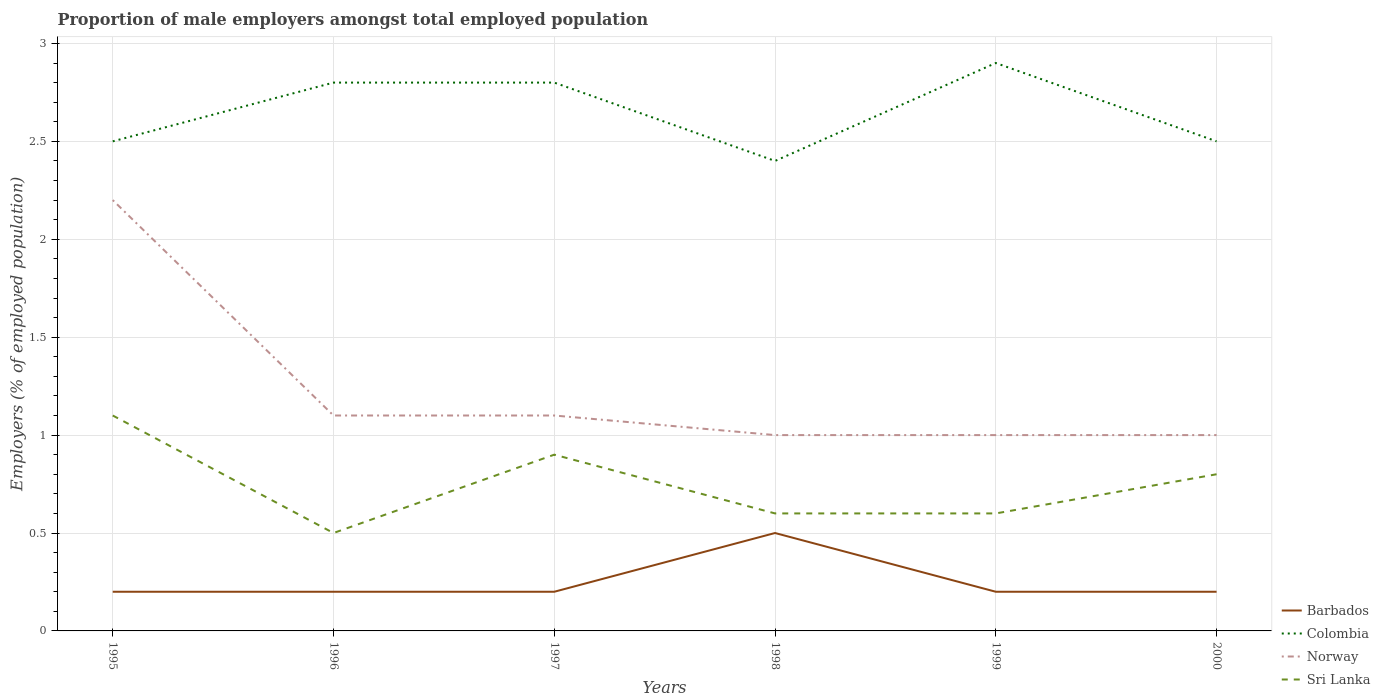How many different coloured lines are there?
Offer a very short reply. 4. Is the number of lines equal to the number of legend labels?
Keep it short and to the point. Yes. Across all years, what is the maximum proportion of male employers in Norway?
Make the answer very short. 1. What is the total proportion of male employers in Norway in the graph?
Your answer should be very brief. 0.1. What is the difference between the highest and the second highest proportion of male employers in Norway?
Provide a short and direct response. 1.2. What is the difference between the highest and the lowest proportion of male employers in Barbados?
Give a very brief answer. 1. How many lines are there?
Provide a succinct answer. 4. How many years are there in the graph?
Your response must be concise. 6. Are the values on the major ticks of Y-axis written in scientific E-notation?
Keep it short and to the point. No. Does the graph contain any zero values?
Provide a short and direct response. No. Does the graph contain grids?
Make the answer very short. Yes. How many legend labels are there?
Offer a very short reply. 4. What is the title of the graph?
Give a very brief answer. Proportion of male employers amongst total employed population. Does "Namibia" appear as one of the legend labels in the graph?
Your answer should be very brief. No. What is the label or title of the Y-axis?
Provide a succinct answer. Employers (% of employed population). What is the Employers (% of employed population) of Barbados in 1995?
Offer a very short reply. 0.2. What is the Employers (% of employed population) in Norway in 1995?
Make the answer very short. 2.2. What is the Employers (% of employed population) in Sri Lanka in 1995?
Make the answer very short. 1.1. What is the Employers (% of employed population) in Barbados in 1996?
Provide a short and direct response. 0.2. What is the Employers (% of employed population) of Colombia in 1996?
Make the answer very short. 2.8. What is the Employers (% of employed population) of Norway in 1996?
Make the answer very short. 1.1. What is the Employers (% of employed population) in Barbados in 1997?
Offer a terse response. 0.2. What is the Employers (% of employed population) in Colombia in 1997?
Offer a terse response. 2.8. What is the Employers (% of employed population) of Norway in 1997?
Your response must be concise. 1.1. What is the Employers (% of employed population) in Sri Lanka in 1997?
Offer a terse response. 0.9. What is the Employers (% of employed population) of Colombia in 1998?
Provide a succinct answer. 2.4. What is the Employers (% of employed population) in Norway in 1998?
Offer a terse response. 1. What is the Employers (% of employed population) of Sri Lanka in 1998?
Give a very brief answer. 0.6. What is the Employers (% of employed population) in Barbados in 1999?
Offer a terse response. 0.2. What is the Employers (% of employed population) of Colombia in 1999?
Make the answer very short. 2.9. What is the Employers (% of employed population) of Norway in 1999?
Offer a very short reply. 1. What is the Employers (% of employed population) in Sri Lanka in 1999?
Offer a terse response. 0.6. What is the Employers (% of employed population) in Barbados in 2000?
Your response must be concise. 0.2. What is the Employers (% of employed population) in Colombia in 2000?
Give a very brief answer. 2.5. What is the Employers (% of employed population) in Norway in 2000?
Offer a very short reply. 1. What is the Employers (% of employed population) of Sri Lanka in 2000?
Provide a succinct answer. 0.8. Across all years, what is the maximum Employers (% of employed population) of Barbados?
Make the answer very short. 0.5. Across all years, what is the maximum Employers (% of employed population) in Colombia?
Your response must be concise. 2.9. Across all years, what is the maximum Employers (% of employed population) in Norway?
Make the answer very short. 2.2. Across all years, what is the maximum Employers (% of employed population) in Sri Lanka?
Your response must be concise. 1.1. Across all years, what is the minimum Employers (% of employed population) in Barbados?
Offer a very short reply. 0.2. Across all years, what is the minimum Employers (% of employed population) in Colombia?
Provide a succinct answer. 2.4. Across all years, what is the minimum Employers (% of employed population) in Sri Lanka?
Your answer should be compact. 0.5. What is the total Employers (% of employed population) of Barbados in the graph?
Provide a short and direct response. 1.5. What is the total Employers (% of employed population) in Colombia in the graph?
Your response must be concise. 15.9. What is the total Employers (% of employed population) of Sri Lanka in the graph?
Ensure brevity in your answer.  4.5. What is the difference between the Employers (% of employed population) of Sri Lanka in 1995 and that in 1996?
Ensure brevity in your answer.  0.6. What is the difference between the Employers (% of employed population) in Barbados in 1995 and that in 1997?
Provide a succinct answer. 0. What is the difference between the Employers (% of employed population) in Barbados in 1995 and that in 1998?
Your response must be concise. -0.3. What is the difference between the Employers (% of employed population) of Colombia in 1995 and that in 1998?
Offer a very short reply. 0.1. What is the difference between the Employers (% of employed population) of Norway in 1995 and that in 1998?
Give a very brief answer. 1.2. What is the difference between the Employers (% of employed population) in Sri Lanka in 1995 and that in 1998?
Offer a terse response. 0.5. What is the difference between the Employers (% of employed population) in Barbados in 1996 and that in 1997?
Provide a short and direct response. 0. What is the difference between the Employers (% of employed population) of Sri Lanka in 1996 and that in 1997?
Your answer should be very brief. -0.4. What is the difference between the Employers (% of employed population) in Barbados in 1996 and that in 1998?
Your response must be concise. -0.3. What is the difference between the Employers (% of employed population) in Barbados in 1996 and that in 2000?
Your answer should be compact. 0. What is the difference between the Employers (% of employed population) of Colombia in 1996 and that in 2000?
Offer a terse response. 0.3. What is the difference between the Employers (% of employed population) of Colombia in 1997 and that in 1998?
Give a very brief answer. 0.4. What is the difference between the Employers (% of employed population) in Norway in 1997 and that in 1998?
Offer a terse response. 0.1. What is the difference between the Employers (% of employed population) in Colombia in 1997 and that in 1999?
Your answer should be very brief. -0.1. What is the difference between the Employers (% of employed population) in Norway in 1997 and that in 1999?
Offer a very short reply. 0.1. What is the difference between the Employers (% of employed population) of Colombia in 1998 and that in 1999?
Your answer should be compact. -0.5. What is the difference between the Employers (% of employed population) of Sri Lanka in 1998 and that in 1999?
Your response must be concise. 0. What is the difference between the Employers (% of employed population) of Barbados in 1998 and that in 2000?
Your answer should be compact. 0.3. What is the difference between the Employers (% of employed population) in Colombia in 1998 and that in 2000?
Provide a short and direct response. -0.1. What is the difference between the Employers (% of employed population) of Barbados in 1999 and that in 2000?
Make the answer very short. 0. What is the difference between the Employers (% of employed population) in Norway in 1999 and that in 2000?
Keep it short and to the point. 0. What is the difference between the Employers (% of employed population) of Barbados in 1995 and the Employers (% of employed population) of Norway in 1996?
Keep it short and to the point. -0.9. What is the difference between the Employers (% of employed population) in Barbados in 1995 and the Employers (% of employed population) in Sri Lanka in 1996?
Give a very brief answer. -0.3. What is the difference between the Employers (% of employed population) of Colombia in 1995 and the Employers (% of employed population) of Sri Lanka in 1996?
Ensure brevity in your answer.  2. What is the difference between the Employers (% of employed population) of Norway in 1995 and the Employers (% of employed population) of Sri Lanka in 1996?
Your response must be concise. 1.7. What is the difference between the Employers (% of employed population) in Barbados in 1995 and the Employers (% of employed population) in Colombia in 1997?
Ensure brevity in your answer.  -2.6. What is the difference between the Employers (% of employed population) of Barbados in 1995 and the Employers (% of employed population) of Sri Lanka in 1997?
Your answer should be compact. -0.7. What is the difference between the Employers (% of employed population) in Barbados in 1995 and the Employers (% of employed population) in Colombia in 1998?
Ensure brevity in your answer.  -2.2. What is the difference between the Employers (% of employed population) in Barbados in 1995 and the Employers (% of employed population) in Sri Lanka in 1998?
Offer a terse response. -0.4. What is the difference between the Employers (% of employed population) of Colombia in 1995 and the Employers (% of employed population) of Norway in 1998?
Your response must be concise. 1.5. What is the difference between the Employers (% of employed population) in Norway in 1995 and the Employers (% of employed population) in Sri Lanka in 1998?
Your answer should be very brief. 1.6. What is the difference between the Employers (% of employed population) of Barbados in 1995 and the Employers (% of employed population) of Colombia in 1999?
Your answer should be very brief. -2.7. What is the difference between the Employers (% of employed population) in Barbados in 1995 and the Employers (% of employed population) in Sri Lanka in 1999?
Ensure brevity in your answer.  -0.4. What is the difference between the Employers (% of employed population) in Colombia in 1995 and the Employers (% of employed population) in Norway in 1999?
Provide a succinct answer. 1.5. What is the difference between the Employers (% of employed population) of Colombia in 1995 and the Employers (% of employed population) of Sri Lanka in 1999?
Provide a succinct answer. 1.9. What is the difference between the Employers (% of employed population) in Barbados in 1995 and the Employers (% of employed population) in Colombia in 2000?
Give a very brief answer. -2.3. What is the difference between the Employers (% of employed population) in Colombia in 1995 and the Employers (% of employed population) in Norway in 2000?
Give a very brief answer. 1.5. What is the difference between the Employers (% of employed population) of Barbados in 1996 and the Employers (% of employed population) of Norway in 1997?
Your answer should be very brief. -0.9. What is the difference between the Employers (% of employed population) of Colombia in 1996 and the Employers (% of employed population) of Sri Lanka in 1997?
Your answer should be compact. 1.9. What is the difference between the Employers (% of employed population) of Barbados in 1996 and the Employers (% of employed population) of Norway in 1998?
Your response must be concise. -0.8. What is the difference between the Employers (% of employed population) in Barbados in 1996 and the Employers (% of employed population) in Sri Lanka in 1999?
Your answer should be compact. -0.4. What is the difference between the Employers (% of employed population) in Colombia in 1996 and the Employers (% of employed population) in Norway in 1999?
Ensure brevity in your answer.  1.8. What is the difference between the Employers (% of employed population) in Colombia in 1996 and the Employers (% of employed population) in Sri Lanka in 1999?
Keep it short and to the point. 2.2. What is the difference between the Employers (% of employed population) in Barbados in 1996 and the Employers (% of employed population) in Norway in 2000?
Offer a terse response. -0.8. What is the difference between the Employers (% of employed population) of Barbados in 1996 and the Employers (% of employed population) of Sri Lanka in 2000?
Give a very brief answer. -0.6. What is the difference between the Employers (% of employed population) in Barbados in 1997 and the Employers (% of employed population) in Colombia in 1998?
Offer a very short reply. -2.2. What is the difference between the Employers (% of employed population) in Barbados in 1997 and the Employers (% of employed population) in Norway in 1998?
Ensure brevity in your answer.  -0.8. What is the difference between the Employers (% of employed population) of Barbados in 1997 and the Employers (% of employed population) of Sri Lanka in 1998?
Provide a succinct answer. -0.4. What is the difference between the Employers (% of employed population) of Barbados in 1997 and the Employers (% of employed population) of Norway in 1999?
Offer a terse response. -0.8. What is the difference between the Employers (% of employed population) in Colombia in 1997 and the Employers (% of employed population) in Norway in 1999?
Make the answer very short. 1.8. What is the difference between the Employers (% of employed population) of Colombia in 1997 and the Employers (% of employed population) of Sri Lanka in 1999?
Provide a succinct answer. 2.2. What is the difference between the Employers (% of employed population) of Barbados in 1997 and the Employers (% of employed population) of Colombia in 2000?
Make the answer very short. -2.3. What is the difference between the Employers (% of employed population) in Colombia in 1997 and the Employers (% of employed population) in Norway in 2000?
Give a very brief answer. 1.8. What is the difference between the Employers (% of employed population) of Colombia in 1997 and the Employers (% of employed population) of Sri Lanka in 2000?
Ensure brevity in your answer.  2. What is the difference between the Employers (% of employed population) of Norway in 1997 and the Employers (% of employed population) of Sri Lanka in 2000?
Provide a succinct answer. 0.3. What is the difference between the Employers (% of employed population) in Barbados in 1998 and the Employers (% of employed population) in Colombia in 1999?
Provide a succinct answer. -2.4. What is the difference between the Employers (% of employed population) of Barbados in 1998 and the Employers (% of employed population) of Sri Lanka in 1999?
Offer a very short reply. -0.1. What is the difference between the Employers (% of employed population) of Colombia in 1998 and the Employers (% of employed population) of Sri Lanka in 1999?
Provide a succinct answer. 1.8. What is the difference between the Employers (% of employed population) of Norway in 1998 and the Employers (% of employed population) of Sri Lanka in 1999?
Offer a very short reply. 0.4. What is the difference between the Employers (% of employed population) of Barbados in 1998 and the Employers (% of employed population) of Colombia in 2000?
Your response must be concise. -2. What is the difference between the Employers (% of employed population) of Colombia in 1998 and the Employers (% of employed population) of Sri Lanka in 2000?
Keep it short and to the point. 1.6. What is the difference between the Employers (% of employed population) of Norway in 1998 and the Employers (% of employed population) of Sri Lanka in 2000?
Offer a terse response. 0.2. What is the difference between the Employers (% of employed population) in Barbados in 1999 and the Employers (% of employed population) in Colombia in 2000?
Provide a short and direct response. -2.3. What is the difference between the Employers (% of employed population) in Colombia in 1999 and the Employers (% of employed population) in Norway in 2000?
Give a very brief answer. 1.9. What is the difference between the Employers (% of employed population) of Colombia in 1999 and the Employers (% of employed population) of Sri Lanka in 2000?
Ensure brevity in your answer.  2.1. What is the difference between the Employers (% of employed population) in Norway in 1999 and the Employers (% of employed population) in Sri Lanka in 2000?
Your answer should be very brief. 0.2. What is the average Employers (% of employed population) of Barbados per year?
Provide a short and direct response. 0.25. What is the average Employers (% of employed population) of Colombia per year?
Make the answer very short. 2.65. What is the average Employers (% of employed population) in Norway per year?
Make the answer very short. 1.23. What is the average Employers (% of employed population) in Sri Lanka per year?
Your answer should be compact. 0.75. In the year 1995, what is the difference between the Employers (% of employed population) of Barbados and Employers (% of employed population) of Norway?
Your answer should be compact. -2. In the year 1995, what is the difference between the Employers (% of employed population) in Colombia and Employers (% of employed population) in Norway?
Give a very brief answer. 0.3. In the year 1995, what is the difference between the Employers (% of employed population) in Colombia and Employers (% of employed population) in Sri Lanka?
Ensure brevity in your answer.  1.4. In the year 1996, what is the difference between the Employers (% of employed population) in Barbados and Employers (% of employed population) in Colombia?
Your response must be concise. -2.6. In the year 1996, what is the difference between the Employers (% of employed population) in Colombia and Employers (% of employed population) in Norway?
Your answer should be compact. 1.7. In the year 1997, what is the difference between the Employers (% of employed population) in Barbados and Employers (% of employed population) in Colombia?
Your answer should be compact. -2.6. In the year 1997, what is the difference between the Employers (% of employed population) of Barbados and Employers (% of employed population) of Sri Lanka?
Your answer should be very brief. -0.7. In the year 1997, what is the difference between the Employers (% of employed population) of Colombia and Employers (% of employed population) of Norway?
Your answer should be very brief. 1.7. In the year 1997, what is the difference between the Employers (% of employed population) in Colombia and Employers (% of employed population) in Sri Lanka?
Your response must be concise. 1.9. In the year 1998, what is the difference between the Employers (% of employed population) in Barbados and Employers (% of employed population) in Norway?
Make the answer very short. -0.5. In the year 1998, what is the difference between the Employers (% of employed population) of Barbados and Employers (% of employed population) of Sri Lanka?
Your response must be concise. -0.1. In the year 1998, what is the difference between the Employers (% of employed population) in Colombia and Employers (% of employed population) in Norway?
Offer a terse response. 1.4. In the year 1998, what is the difference between the Employers (% of employed population) of Norway and Employers (% of employed population) of Sri Lanka?
Your response must be concise. 0.4. In the year 1999, what is the difference between the Employers (% of employed population) of Barbados and Employers (% of employed population) of Sri Lanka?
Provide a short and direct response. -0.4. In the year 1999, what is the difference between the Employers (% of employed population) of Colombia and Employers (% of employed population) of Norway?
Your response must be concise. 1.9. In the year 1999, what is the difference between the Employers (% of employed population) in Norway and Employers (% of employed population) in Sri Lanka?
Make the answer very short. 0.4. What is the ratio of the Employers (% of employed population) in Colombia in 1995 to that in 1996?
Your answer should be compact. 0.89. What is the ratio of the Employers (% of employed population) of Norway in 1995 to that in 1996?
Keep it short and to the point. 2. What is the ratio of the Employers (% of employed population) of Colombia in 1995 to that in 1997?
Your response must be concise. 0.89. What is the ratio of the Employers (% of employed population) in Sri Lanka in 1995 to that in 1997?
Your response must be concise. 1.22. What is the ratio of the Employers (% of employed population) of Colombia in 1995 to that in 1998?
Your response must be concise. 1.04. What is the ratio of the Employers (% of employed population) in Norway in 1995 to that in 1998?
Provide a short and direct response. 2.2. What is the ratio of the Employers (% of employed population) of Sri Lanka in 1995 to that in 1998?
Provide a succinct answer. 1.83. What is the ratio of the Employers (% of employed population) in Colombia in 1995 to that in 1999?
Offer a terse response. 0.86. What is the ratio of the Employers (% of employed population) of Sri Lanka in 1995 to that in 1999?
Provide a short and direct response. 1.83. What is the ratio of the Employers (% of employed population) of Barbados in 1995 to that in 2000?
Your answer should be very brief. 1. What is the ratio of the Employers (% of employed population) of Colombia in 1995 to that in 2000?
Provide a short and direct response. 1. What is the ratio of the Employers (% of employed population) of Norway in 1995 to that in 2000?
Offer a terse response. 2.2. What is the ratio of the Employers (% of employed population) in Sri Lanka in 1995 to that in 2000?
Your answer should be compact. 1.38. What is the ratio of the Employers (% of employed population) in Colombia in 1996 to that in 1997?
Provide a succinct answer. 1. What is the ratio of the Employers (% of employed population) in Sri Lanka in 1996 to that in 1997?
Offer a very short reply. 0.56. What is the ratio of the Employers (% of employed population) of Colombia in 1996 to that in 1998?
Keep it short and to the point. 1.17. What is the ratio of the Employers (% of employed population) in Sri Lanka in 1996 to that in 1998?
Provide a short and direct response. 0.83. What is the ratio of the Employers (% of employed population) of Barbados in 1996 to that in 1999?
Offer a very short reply. 1. What is the ratio of the Employers (% of employed population) in Colombia in 1996 to that in 1999?
Keep it short and to the point. 0.97. What is the ratio of the Employers (% of employed population) in Norway in 1996 to that in 1999?
Provide a short and direct response. 1.1. What is the ratio of the Employers (% of employed population) in Colombia in 1996 to that in 2000?
Your answer should be very brief. 1.12. What is the ratio of the Employers (% of employed population) of Sri Lanka in 1996 to that in 2000?
Keep it short and to the point. 0.62. What is the ratio of the Employers (% of employed population) of Colombia in 1997 to that in 1998?
Offer a terse response. 1.17. What is the ratio of the Employers (% of employed population) in Sri Lanka in 1997 to that in 1998?
Make the answer very short. 1.5. What is the ratio of the Employers (% of employed population) in Colombia in 1997 to that in 1999?
Make the answer very short. 0.97. What is the ratio of the Employers (% of employed population) in Norway in 1997 to that in 1999?
Offer a very short reply. 1.1. What is the ratio of the Employers (% of employed population) in Sri Lanka in 1997 to that in 1999?
Your response must be concise. 1.5. What is the ratio of the Employers (% of employed population) in Barbados in 1997 to that in 2000?
Your response must be concise. 1. What is the ratio of the Employers (% of employed population) of Colombia in 1997 to that in 2000?
Ensure brevity in your answer.  1.12. What is the ratio of the Employers (% of employed population) in Norway in 1997 to that in 2000?
Ensure brevity in your answer.  1.1. What is the ratio of the Employers (% of employed population) of Colombia in 1998 to that in 1999?
Offer a very short reply. 0.83. What is the ratio of the Employers (% of employed population) in Sri Lanka in 1998 to that in 1999?
Provide a succinct answer. 1. What is the ratio of the Employers (% of employed population) in Colombia in 1999 to that in 2000?
Offer a terse response. 1.16. What is the ratio of the Employers (% of employed population) in Norway in 1999 to that in 2000?
Provide a short and direct response. 1. What is the difference between the highest and the second highest Employers (% of employed population) in Barbados?
Your answer should be very brief. 0.3. What is the difference between the highest and the second highest Employers (% of employed population) of Norway?
Ensure brevity in your answer.  1.1. What is the difference between the highest and the second highest Employers (% of employed population) in Sri Lanka?
Provide a succinct answer. 0.2. What is the difference between the highest and the lowest Employers (% of employed population) in Colombia?
Offer a very short reply. 0.5. 